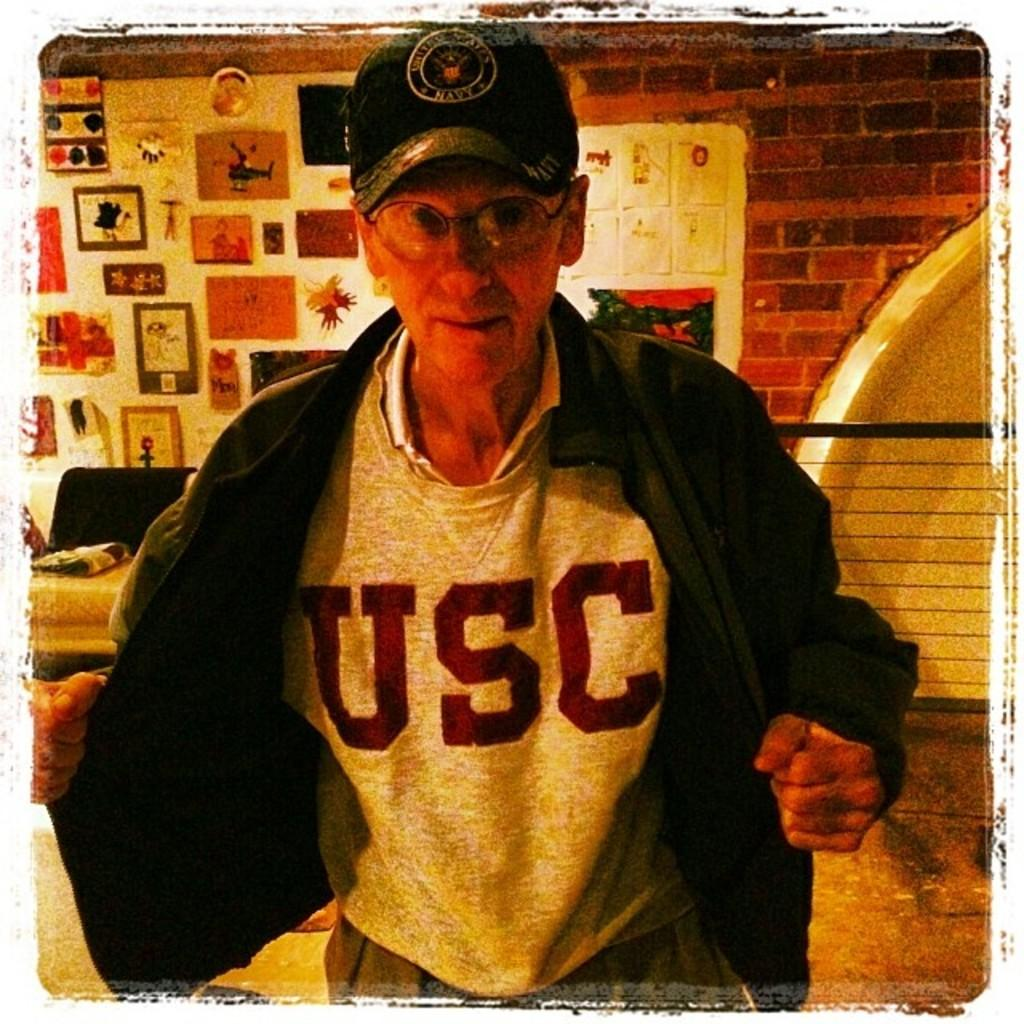<image>
Provide a brief description of the given image. An elderly man opens his jacket to show off his USC t-shirt. 